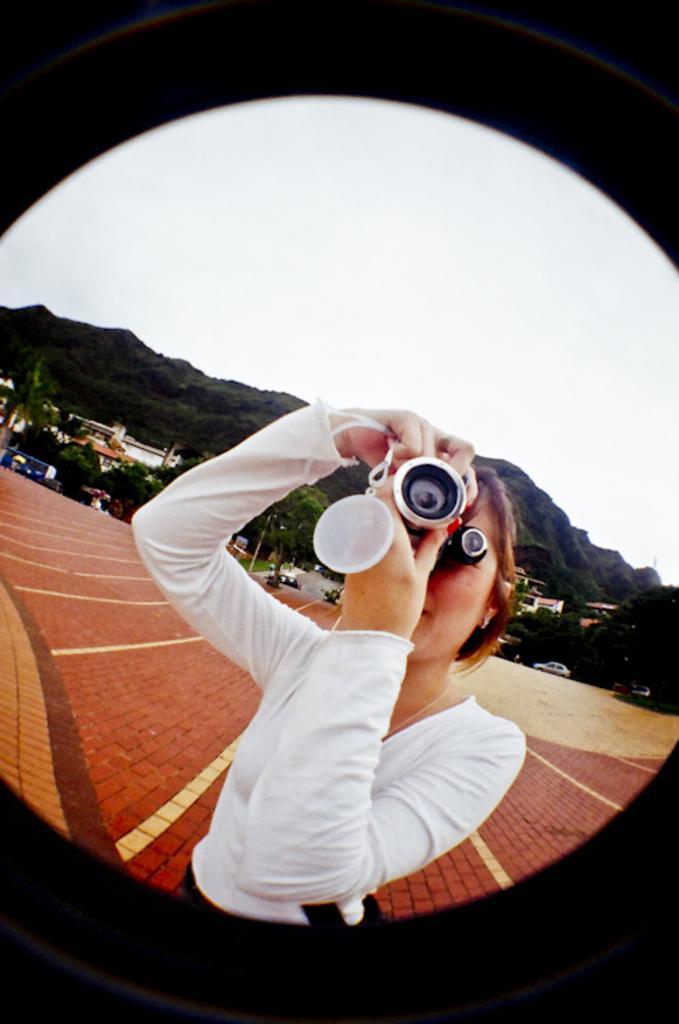How would you summarize this image in a sentence or two? In the image a woman is standing and holding something in her hands. Behind her there are some trees and hill. At the top of the image there is sky. Bottom right side of the image there is a car. 